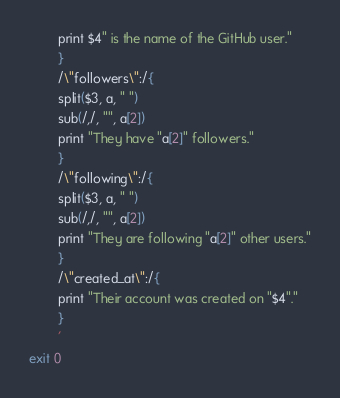Convert code to text. <code><loc_0><loc_0><loc_500><loc_500><_Bash_>		print $4" is the name of the GitHub user."
		}
		/\"followers\":/{
		split($3, a, " ")
		sub(/,/, "", a[2])
		print "They have "a[2]" followers."
		}
		/\"following\":/{
		split($3, a, " ")
		sub(/,/, "", a[2])
		print "They are following "a[2]" other users."
		}
		/\"created_at\":/{
		print "Their account was created on "$4"."
		}
		'
exit 0
</code> 